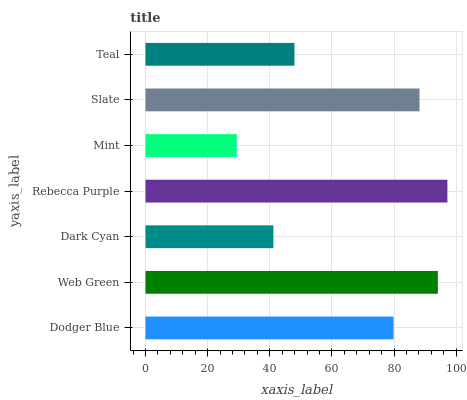Is Mint the minimum?
Answer yes or no. Yes. Is Rebecca Purple the maximum?
Answer yes or no. Yes. Is Web Green the minimum?
Answer yes or no. No. Is Web Green the maximum?
Answer yes or no. No. Is Web Green greater than Dodger Blue?
Answer yes or no. Yes. Is Dodger Blue less than Web Green?
Answer yes or no. Yes. Is Dodger Blue greater than Web Green?
Answer yes or no. No. Is Web Green less than Dodger Blue?
Answer yes or no. No. Is Dodger Blue the high median?
Answer yes or no. Yes. Is Dodger Blue the low median?
Answer yes or no. Yes. Is Mint the high median?
Answer yes or no. No. Is Mint the low median?
Answer yes or no. No. 